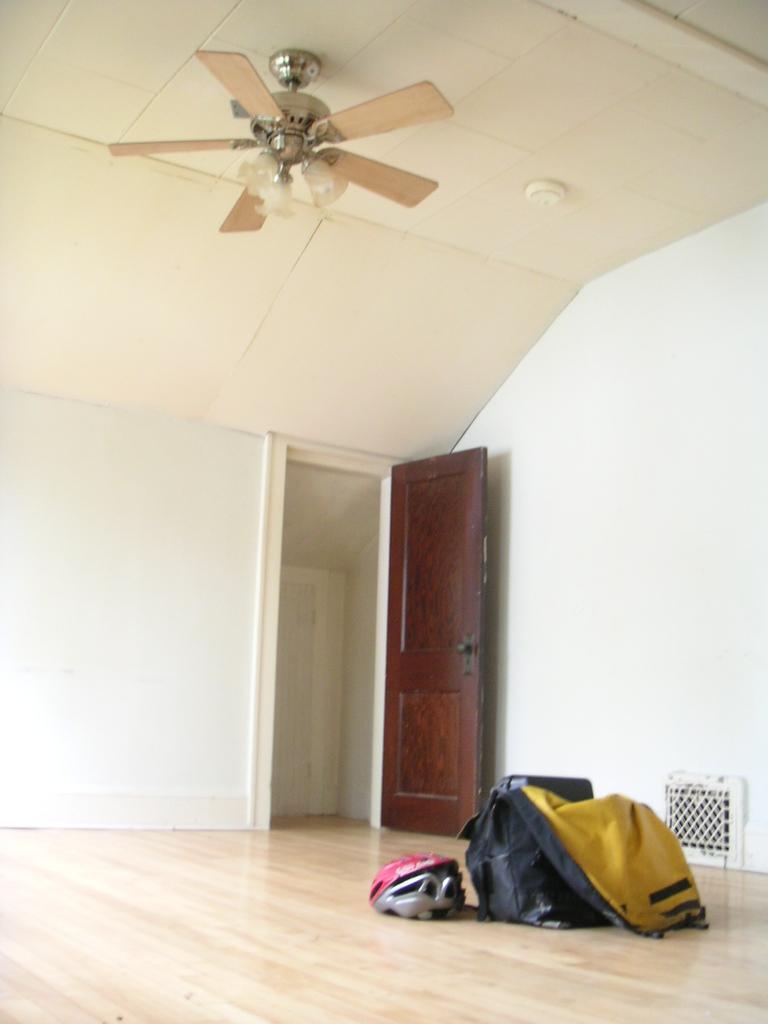How would you summarize this image in a sentence or two? In this image in the center there is a bag and there is a pink colour helmet on the floor. In the background there is a door, on the top there is a fan and there is a wall which is white in colour. 